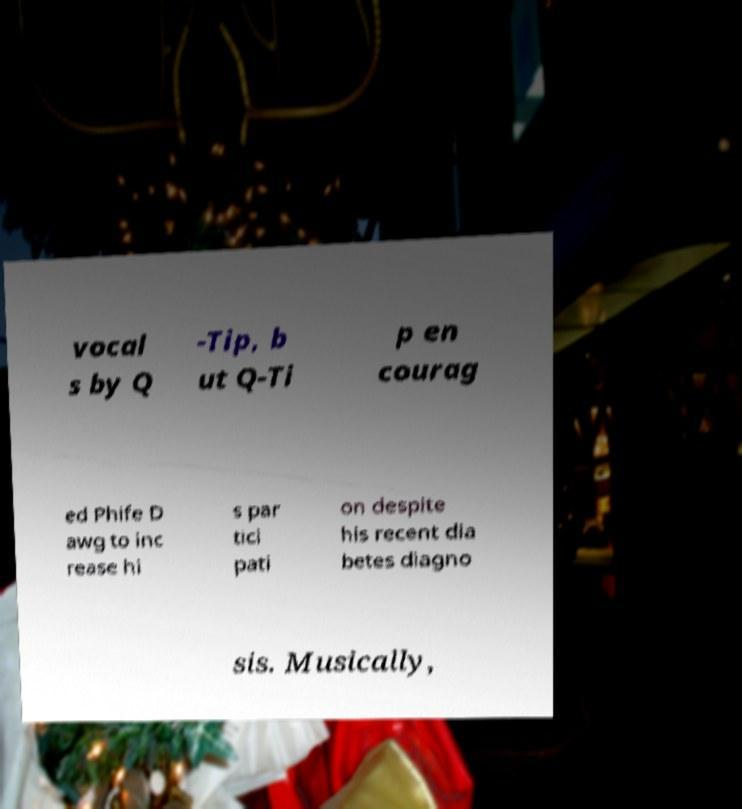Could you extract and type out the text from this image? vocal s by Q -Tip, b ut Q-Ti p en courag ed Phife D awg to inc rease hi s par tici pati on despite his recent dia betes diagno sis. Musically, 